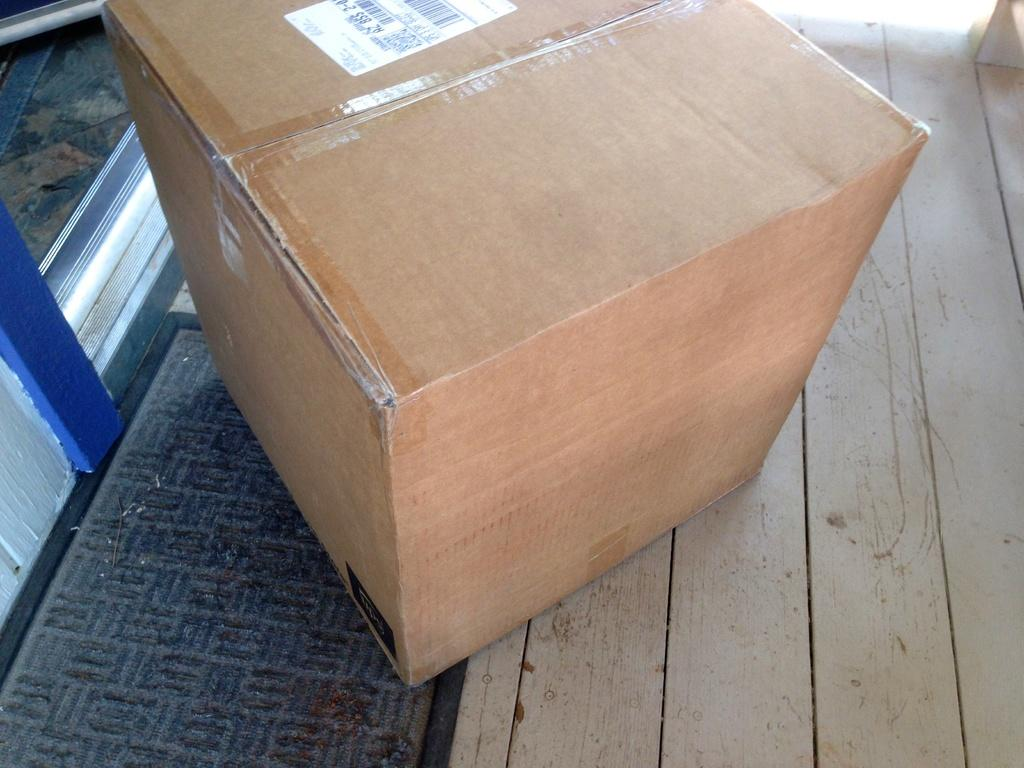What is the main object in the image? There is a carton box in the image. What is the carton box placed on? The carton box is on a wooden surface. What type of ocean can be seen in the image? There is no ocean present in the image. 